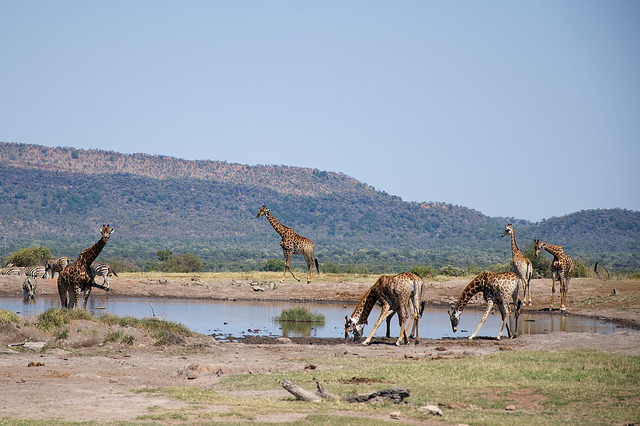<image>About how many animals are out there in the wild? It is unknown how many animals are out there in the wild. The number can vary. About how many animals are out there in the wild? It is unclear about how many animals are out there in the wild. It can be seen as 10 or 7. 